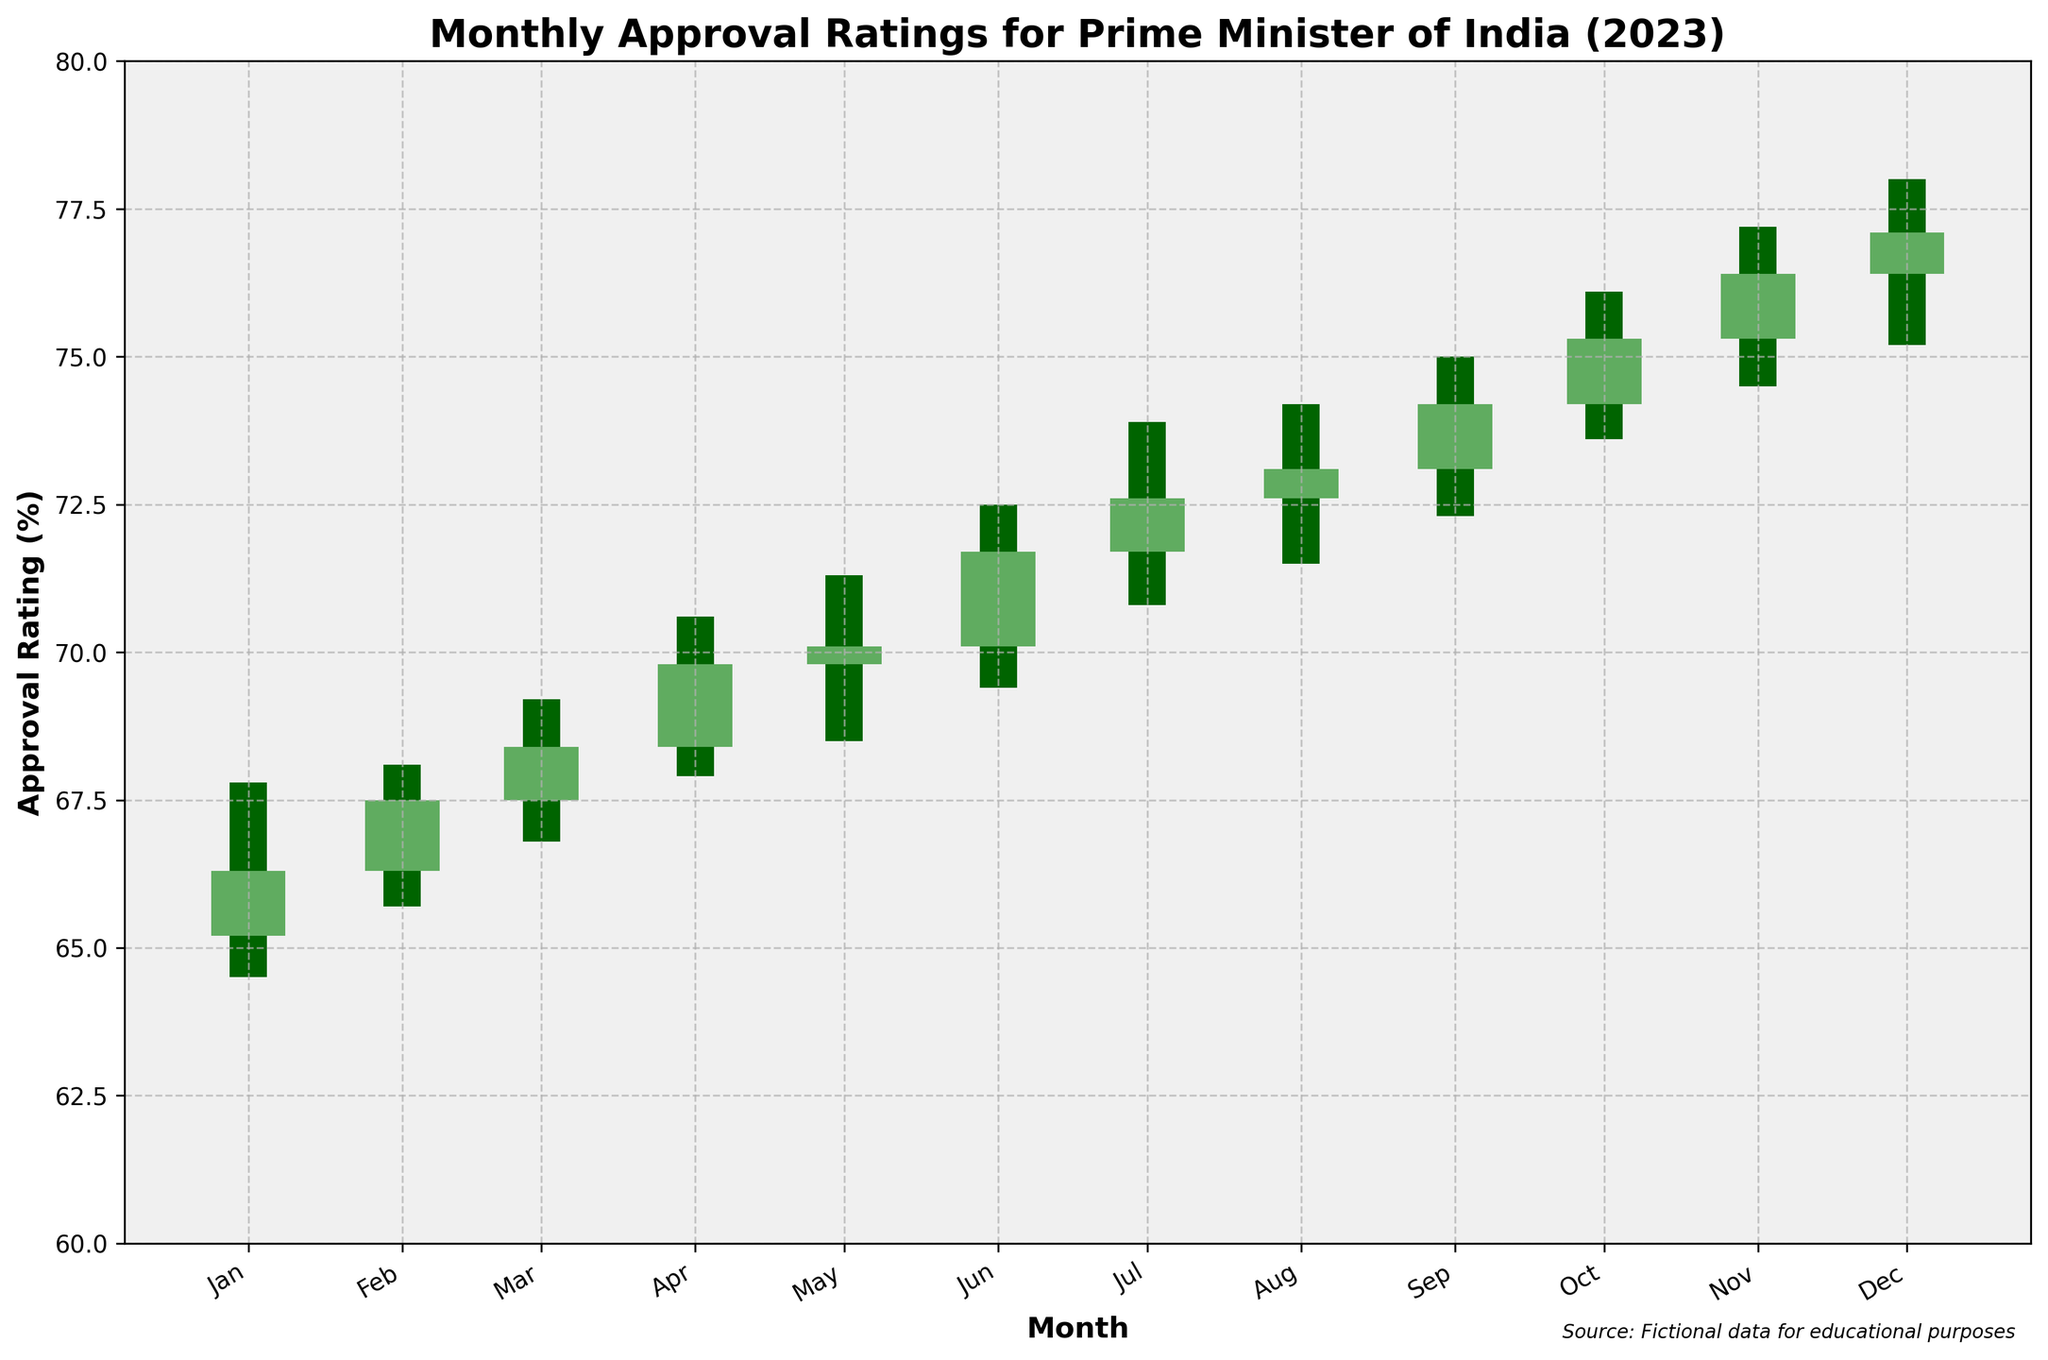What is the title of the plot? The title of the plot is usually displayed prominently at the top. In this case, it is "Monthly Approval Ratings for Prime Minister of India (2023)"
Answer: Monthly Approval Ratings for Prime Minister of India (2023) What is the approval rating for the Prime Minister at the end of December 2023? The approval rating at the end of December 2023 corresponds to the "Close" value for that month, which is displayed as 77.1% in the dataset.
Answer: 77.1% Which month had the highest high value in the year 2023? By checking the "High" values for each month, we see that December 2023 had the highest value at 78.0%.
Answer: December 2023 Compare the opening approval rating in January 2023 with February 2023. Which one is higher? By looking at the "Open" values for January 2023 (65.2%) and February 2023 (66.3%), we can see that February's opening rating is higher.
Answer: February 2023 What was the lowest approval rating recorded in March 2023? The lowest approval rating for March 2023 can be found in the "Low" value for that month, which is 66.8%.
Answer: 66.8% Which months saw an increase in the closing approval rating compared to their opening rating? To determine this, compare the "Open" and "Close" values for each month: Jan 2023 (65.2 to 66.3), Feb 2023 (66.3 to 67.5), Mar 2023 (67.5 to 68.4), Apr 2023 (68.4 to 69.8), May 2023 (69.8 to 70.1), Jun 2023 (70.1 to 71.7), Jul 2023 (71.7 to 72.6), Aug 2023 (72.6 to 73.1), Sep 2023 (73.1 to 74.2), Oct 2023 (74.2 to 75.3), Nov 2023 (75.3 to 76.4), Dec 2023 (76.4 to 77.1). All months show an increase.
Answer: All months Which month had the smallest difference between its high and low approval ratings? To find this, calculate the difference between "High" and "Low" for each month. The month with the smallest difference is determined by: Jan 2023 (3.3), Feb 2023 (2.4), Mar 2023 (2.4), Apr 2023 (2.7), May 2023 (2.8), Jun 2023 (3.1), Jul 2023 (3.1), Aug 2023 (2.7), Sep 2023 (2.7), Oct 2023 (2.5), Nov 2023 (2.7), Dec 2023 (2.8). The smallest differences are in Feb 2023 and Mar 2023, both at 2.4
Answer: February 2023 and March 2023 What is the average closing approval rating for the first quarter of 2023? The first quarter includes January, February, and March. Their closing values are 66.3, 67.5, and 68.4 respectively. To find the average: (66.3 + 67.5 + 68.4) / 3 = 67.4%
Answer: 67.4% How many months had a closing approval rating higher than 70%? Checking the "Close" values, the months are: Jun 2023 (71.7%), Jul 2023 (72.6%), Aug 2023 (73.1%), Sep 2023 (74.2%), Oct 2023 (75.3%), Nov 2023 (76.4%), Dec 2023 (77.1%). This counts to 7 months.
Answer: 7 months 